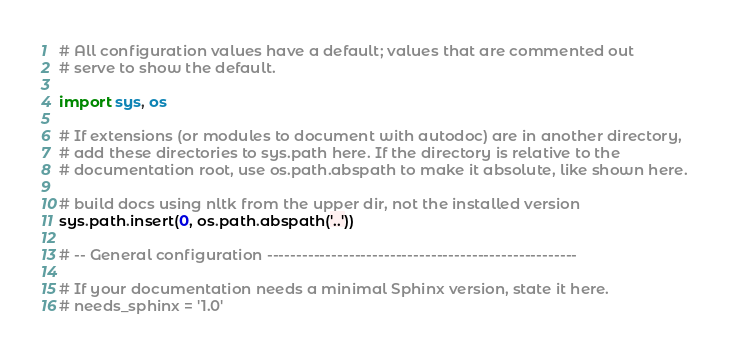Convert code to text. <code><loc_0><loc_0><loc_500><loc_500><_Python_># All configuration values have a default; values that are commented out
# serve to show the default.

import sys, os

# If extensions (or modules to document with autodoc) are in another directory,
# add these directories to sys.path here. If the directory is relative to the
# documentation root, use os.path.abspath to make it absolute, like shown here.

# build docs using nltk from the upper dir, not the installed version
sys.path.insert(0, os.path.abspath('..'))

# -- General configuration -----------------------------------------------------

# If your documentation needs a minimal Sphinx version, state it here.
# needs_sphinx = '1.0'
</code> 